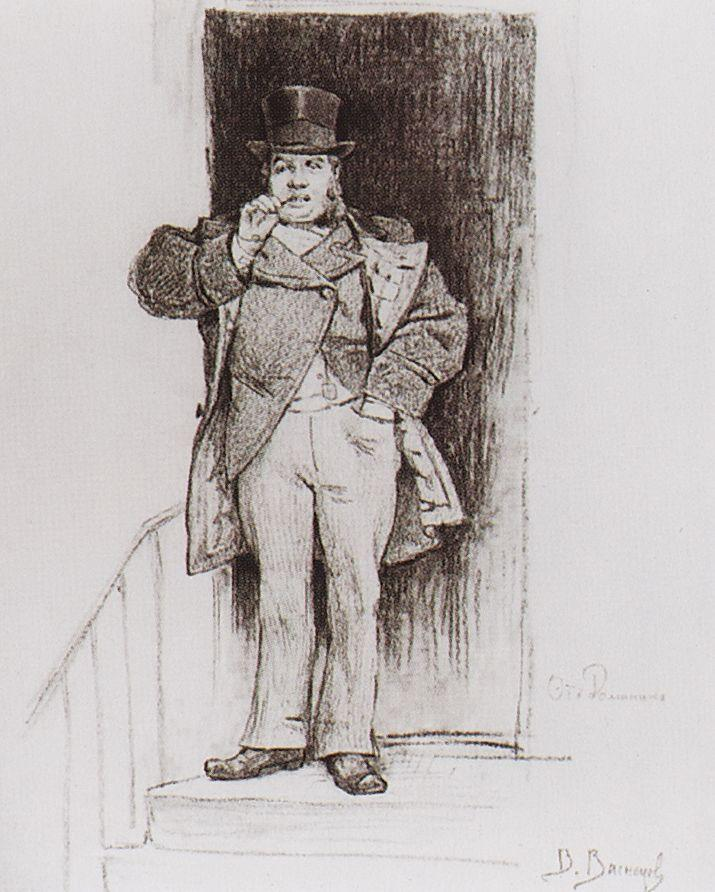Describe the artistic techniques used in this sketch. The artist employs a monochrome palette, utilizing varied line thickness to create depth and texture. The fine lines meticulously detail the fabric of the man's coat and the smoothness of his hat, while softer shading is used to capture the light on his face and hands. This technique not only adds realism to the depiction but also emphasizes the different materials and surfaces depicted in the sketch. 